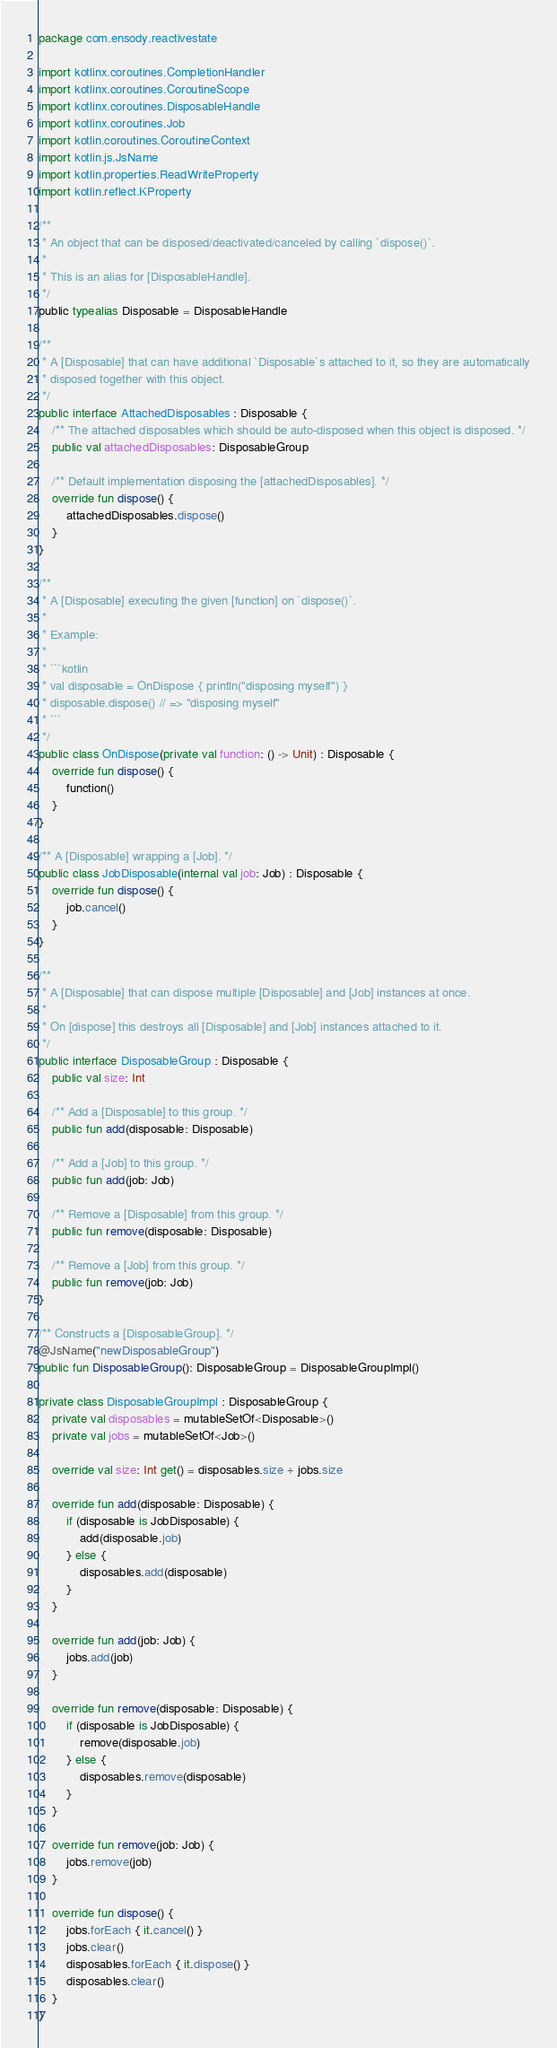<code> <loc_0><loc_0><loc_500><loc_500><_Kotlin_>package com.ensody.reactivestate

import kotlinx.coroutines.CompletionHandler
import kotlinx.coroutines.CoroutineScope
import kotlinx.coroutines.DisposableHandle
import kotlinx.coroutines.Job
import kotlin.coroutines.CoroutineContext
import kotlin.js.JsName
import kotlin.properties.ReadWriteProperty
import kotlin.reflect.KProperty

/**
 * An object that can be disposed/deactivated/canceled by calling `dispose()`.
 *
 * This is an alias for [DisposableHandle].
 */
public typealias Disposable = DisposableHandle

/**
 * A [Disposable] that can have additional `Disposable`s attached to it, so they are automatically
 * disposed together with this object.
 */
public interface AttachedDisposables : Disposable {
    /** The attached disposables which should be auto-disposed when this object is disposed. */
    public val attachedDisposables: DisposableGroup

    /** Default implementation disposing the [attachedDisposables]. */
    override fun dispose() {
        attachedDisposables.dispose()
    }
}

/**
 * A [Disposable] executing the given [function] on `dispose()`.
 *
 * Example:
 *
 * ```kotlin
 * val disposable = OnDispose { println("disposing myself") }
 * disposable.dispose() // => "disposing myself"
 * ```
 */
public class OnDispose(private val function: () -> Unit) : Disposable {
    override fun dispose() {
        function()
    }
}

/** A [Disposable] wrapping a [Job]. */
public class JobDisposable(internal val job: Job) : Disposable {
    override fun dispose() {
        job.cancel()
    }
}

/**
 * A [Disposable] that can dispose multiple [Disposable] and [Job] instances at once.
 *
 * On [dispose] this destroys all [Disposable] and [Job] instances attached to it.
 */
public interface DisposableGroup : Disposable {
    public val size: Int

    /** Add a [Disposable] to this group. */
    public fun add(disposable: Disposable)

    /** Add a [Job] to this group. */
    public fun add(job: Job)

    /** Remove a [Disposable] from this group. */
    public fun remove(disposable: Disposable)

    /** Remove a [Job] from this group. */
    public fun remove(job: Job)
}

/** Constructs a [DisposableGroup]. */
@JsName("newDisposableGroup")
public fun DisposableGroup(): DisposableGroup = DisposableGroupImpl()

private class DisposableGroupImpl : DisposableGroup {
    private val disposables = mutableSetOf<Disposable>()
    private val jobs = mutableSetOf<Job>()

    override val size: Int get() = disposables.size + jobs.size

    override fun add(disposable: Disposable) {
        if (disposable is JobDisposable) {
            add(disposable.job)
        } else {
            disposables.add(disposable)
        }
    }

    override fun add(job: Job) {
        jobs.add(job)
    }

    override fun remove(disposable: Disposable) {
        if (disposable is JobDisposable) {
            remove(disposable.job)
        } else {
            disposables.remove(disposable)
        }
    }

    override fun remove(job: Job) {
        jobs.remove(job)
    }

    override fun dispose() {
        jobs.forEach { it.cancel() }
        jobs.clear()
        disposables.forEach { it.dispose() }
        disposables.clear()
    }
}
</code> 